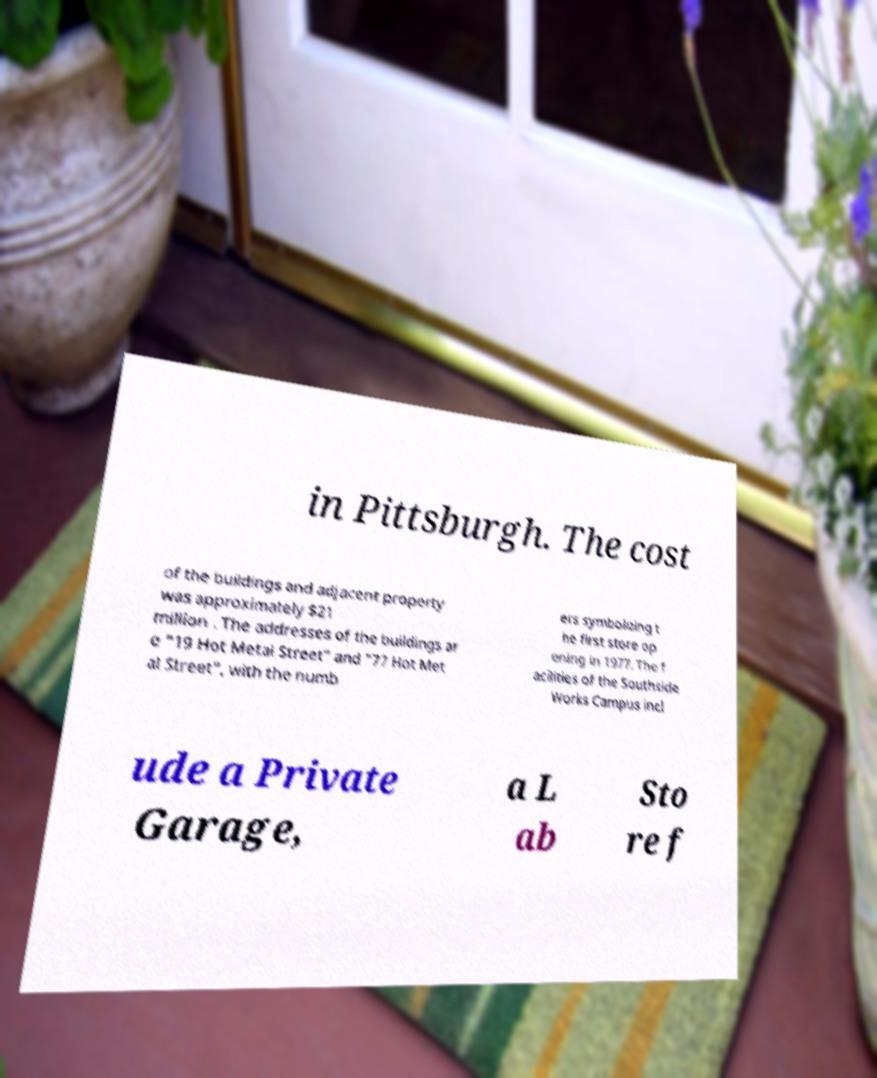Could you extract and type out the text from this image? in Pittsburgh. The cost of the buildings and adjacent property was approximately $21 million . The addresses of the buildings ar e "19 Hot Metal Street" and "77 Hot Met al Street", with the numb ers symbolizing t he first store op ening in 1977. The f acilities of the Southside Works Campus incl ude a Private Garage, a L ab Sto re f 